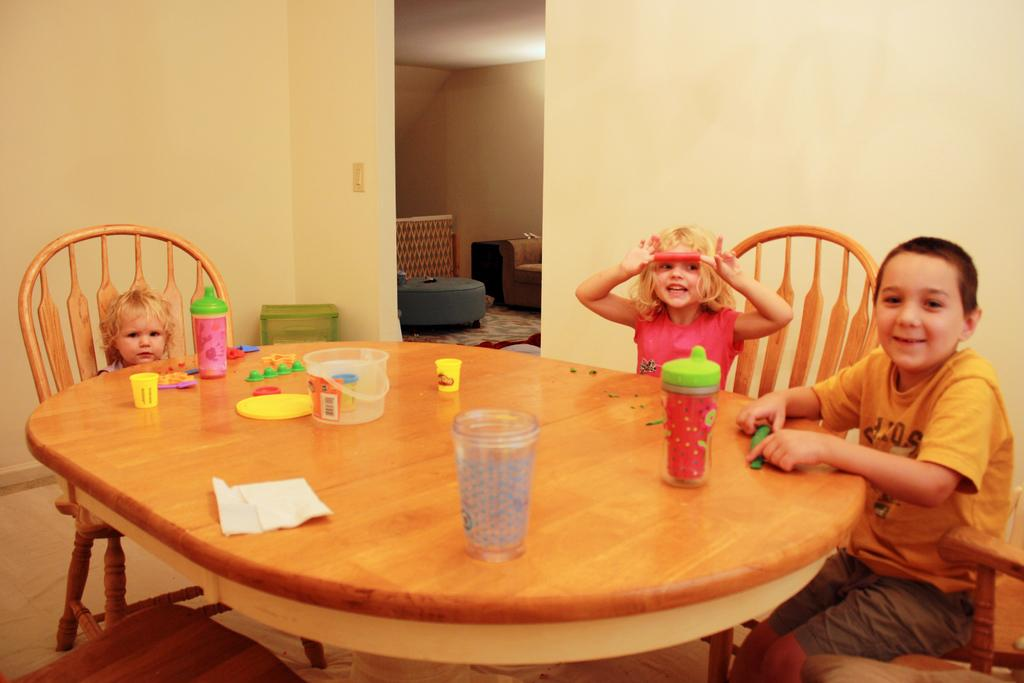What type of furniture is in the image? There is a table in the image. What is on the table? Glass and bottles are on the table. How many chairs are in the image? There are three chairs in the image. What are the chairs being used for? Three people are sitting on the chairs. What can be seen in the background of the image? There are walls visible in the image. Can you describe the next room? There is a sofa in the next room. What type of brush is being used by the person sitting on the left chair? There is no brush visible in the image, and no person is using a brush. 